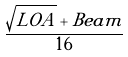Convert formula to latex. <formula><loc_0><loc_0><loc_500><loc_500>\frac { \sqrt { L O A } + B e a m } { 1 6 }</formula> 